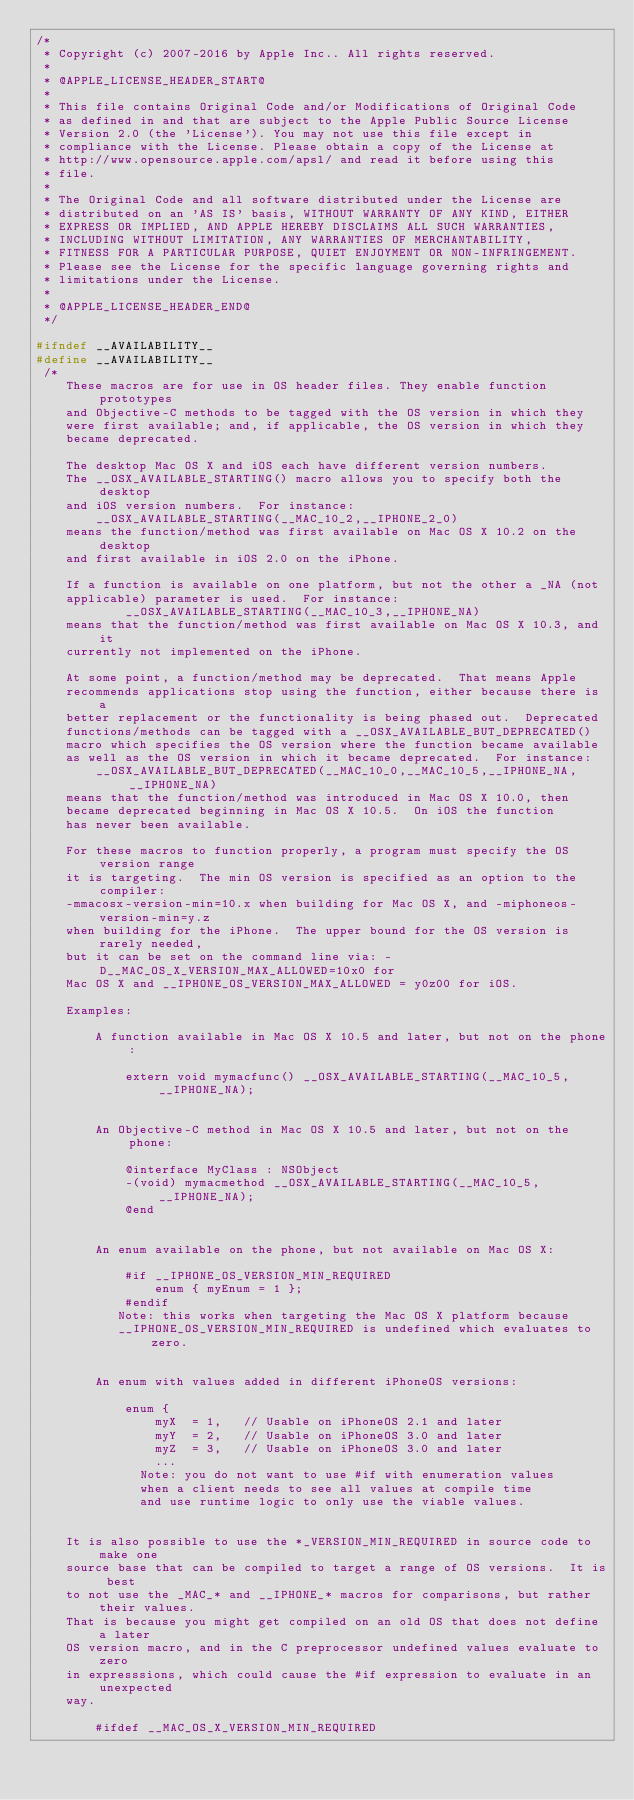Convert code to text. <code><loc_0><loc_0><loc_500><loc_500><_C_>/*
 * Copyright (c) 2007-2016 by Apple Inc.. All rights reserved.
 *
 * @APPLE_LICENSE_HEADER_START@
 * 
 * This file contains Original Code and/or Modifications of Original Code
 * as defined in and that are subject to the Apple Public Source License
 * Version 2.0 (the 'License'). You may not use this file except in
 * compliance with the License. Please obtain a copy of the License at
 * http://www.opensource.apple.com/apsl/ and read it before using this
 * file.
 * 
 * The Original Code and all software distributed under the License are
 * distributed on an 'AS IS' basis, WITHOUT WARRANTY OF ANY KIND, EITHER
 * EXPRESS OR IMPLIED, AND APPLE HEREBY DISCLAIMS ALL SUCH WARRANTIES,
 * INCLUDING WITHOUT LIMITATION, ANY WARRANTIES OF MERCHANTABILITY,
 * FITNESS FOR A PARTICULAR PURPOSE, QUIET ENJOYMENT OR NON-INFRINGEMENT.
 * Please see the License for the specific language governing rights and
 * limitations under the License.
 * 
 * @APPLE_LICENSE_HEADER_END@
 */
 
#ifndef __AVAILABILITY__
#define __AVAILABILITY__
 /*     
    These macros are for use in OS header files. They enable function prototypes
    and Objective-C methods to be tagged with the OS version in which they
    were first available; and, if applicable, the OS version in which they 
    became deprecated.  
     
    The desktop Mac OS X and iOS each have different version numbers.
    The __OSX_AVAILABLE_STARTING() macro allows you to specify both the desktop
    and iOS version numbers.  For instance:
        __OSX_AVAILABLE_STARTING(__MAC_10_2,__IPHONE_2_0)
    means the function/method was first available on Mac OS X 10.2 on the desktop
    and first available in iOS 2.0 on the iPhone.
    
    If a function is available on one platform, but not the other a _NA (not
    applicable) parameter is used.  For instance:
            __OSX_AVAILABLE_STARTING(__MAC_10_3,__IPHONE_NA)
    means that the function/method was first available on Mac OS X 10.3, and it
    currently not implemented on the iPhone.

    At some point, a function/method may be deprecated.  That means Apple
    recommends applications stop using the function, either because there is a 
    better replacement or the functionality is being phased out.  Deprecated
    functions/methods can be tagged with a __OSX_AVAILABLE_BUT_DEPRECATED()
    macro which specifies the OS version where the function became available
    as well as the OS version in which it became deprecated.  For instance:
        __OSX_AVAILABLE_BUT_DEPRECATED(__MAC_10_0,__MAC_10_5,__IPHONE_NA,__IPHONE_NA)
    means that the function/method was introduced in Mac OS X 10.0, then
    became deprecated beginning in Mac OS X 10.5.  On iOS the function 
    has never been available.  
    
    For these macros to function properly, a program must specify the OS version range 
    it is targeting.  The min OS version is specified as an option to the compiler:
    -mmacosx-version-min=10.x when building for Mac OS X, and -miphoneos-version-min=y.z
    when building for the iPhone.  The upper bound for the OS version is rarely needed,
    but it can be set on the command line via: -D__MAC_OS_X_VERSION_MAX_ALLOWED=10x0 for
    Mac OS X and __IPHONE_OS_VERSION_MAX_ALLOWED = y0z00 for iOS.  
    
    Examples:

        A function available in Mac OS X 10.5 and later, but not on the phone:
        
            extern void mymacfunc() __OSX_AVAILABLE_STARTING(__MAC_10_5,__IPHONE_NA);


        An Objective-C method in Mac OS X 10.5 and later, but not on the phone:
        
            @interface MyClass : NSObject
            -(void) mymacmethod __OSX_AVAILABLE_STARTING(__MAC_10_5,__IPHONE_NA);
            @end

        
        An enum available on the phone, but not available on Mac OS X:
        
            #if __IPHONE_OS_VERSION_MIN_REQUIRED
                enum { myEnum = 1 };
            #endif
           Note: this works when targeting the Mac OS X platform because 
           __IPHONE_OS_VERSION_MIN_REQUIRED is undefined which evaluates to zero. 
        

        An enum with values added in different iPhoneOS versions:
		
			enum {
			    myX  = 1,	// Usable on iPhoneOS 2.1 and later
			    myY  = 2,	// Usable on iPhoneOS 3.0 and later
			    myZ  = 3,	// Usable on iPhoneOS 3.0 and later
				...
		      Note: you do not want to use #if with enumeration values
			  when a client needs to see all values at compile time
			  and use runtime logic to only use the viable values.
			  

    It is also possible to use the *_VERSION_MIN_REQUIRED in source code to make one
    source base that can be compiled to target a range of OS versions.  It is best
    to not use the _MAC_* and __IPHONE_* macros for comparisons, but rather their values.
    That is because you might get compiled on an old OS that does not define a later
    OS version macro, and in the C preprocessor undefined values evaluate to zero
    in expresssions, which could cause the #if expression to evaluate in an unexpected
    way.
    
        #ifdef __MAC_OS_X_VERSION_MIN_REQUIRED</code> 